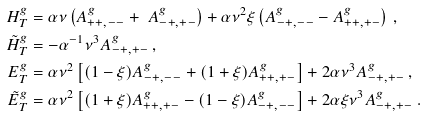Convert formula to latex. <formula><loc_0><loc_0><loc_500><loc_500>H _ { T } ^ { g } & = \alpha \nu \left ( A _ { + + , - - } ^ { g } + \ A _ { - + , + - } ^ { g } \right ) + \alpha \nu ^ { 2 } \xi \left ( A _ { - + , - - } ^ { g } - A _ { + + , + - } ^ { g } \right ) \, , \\ \tilde { H } _ { T } ^ { g } & = - \alpha ^ { - 1 } \nu ^ { 3 } A _ { - + , + - } ^ { g } \, , \\ E _ { T } ^ { g } & = \alpha \nu ^ { 2 } \left [ ( 1 - \xi ) A _ { - + , - - } ^ { g } + ( 1 + \xi ) A _ { + + , + - } ^ { g } \right ] + 2 \alpha \nu ^ { 3 } A _ { - + , + - } ^ { g } \, , \\ \tilde { E } _ { T } ^ { g } & = \alpha \nu ^ { 2 } \left [ ( 1 + \xi ) A _ { + + , + - } ^ { g } - ( 1 - \xi ) A _ { - + , - - } ^ { g } \right ] + 2 \alpha \xi \nu ^ { 3 } A _ { - + , + - } ^ { g } \, .</formula> 